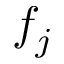<formula> <loc_0><loc_0><loc_500><loc_500>f _ { j }</formula> 